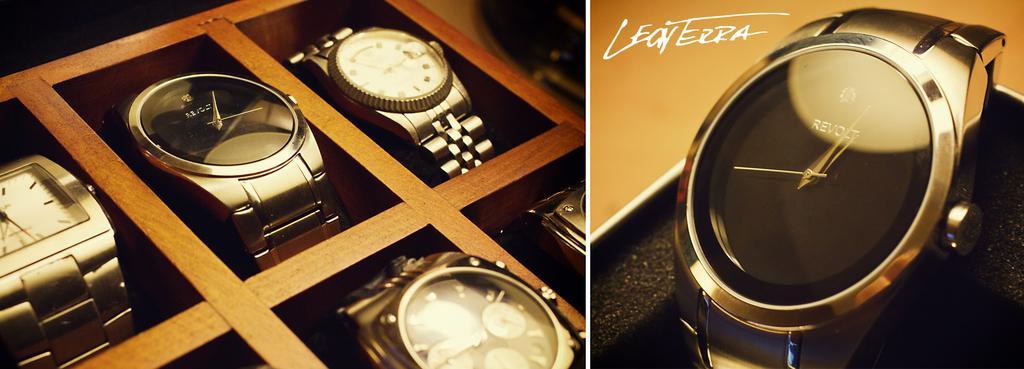Please provide a concise description of this image. There are two images. In the first image, there are watches arranged on the wooden shelves. In the second image, there is a watch arranged on the shelf. On the top left, there is a watermark. 